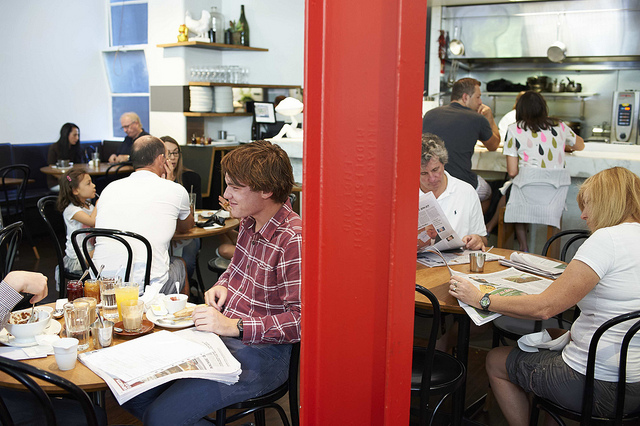Describe the interaction between the two people in the foreground. A young individual with red hair is seated at a table reading a newspaper, seemingly absorbed in the content. Adjacent to them, an older individual is also reading. They appear to be in their own worlds, suggesting a shared yet independent experience. 